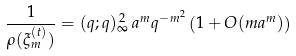<formula> <loc_0><loc_0><loc_500><loc_500>\frac { 1 } { \rho ( \xi _ { m } ^ { ( t ) } ) } = ( q ; q ) _ { \infty } ^ { \, 2 } \, a ^ { m } q ^ { - m ^ { 2 } } \left ( 1 + O ( m a ^ { m } ) \right )</formula> 